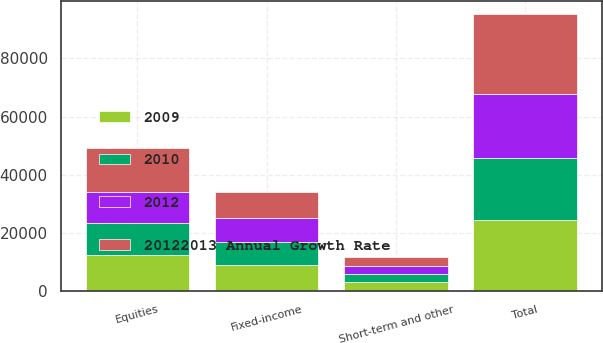Convert chart to OTSL. <chart><loc_0><loc_0><loc_500><loc_500><stacked_bar_chart><ecel><fcel>Equities<fcel>Fixed-income<fcel>Short-term and other<fcel>Total<nl><fcel>20122013 Annual Growth Rate<fcel>15050<fcel>9072<fcel>3305<fcel>27427<nl><fcel>2009<fcel>12276<fcel>8885<fcel>3210<fcel>24371<nl><fcel>2012<fcel>10849<fcel>8317<fcel>2641<fcel>21807<nl><fcel>2010<fcel>11000<fcel>7875<fcel>2652<fcel>21527<nl></chart> 